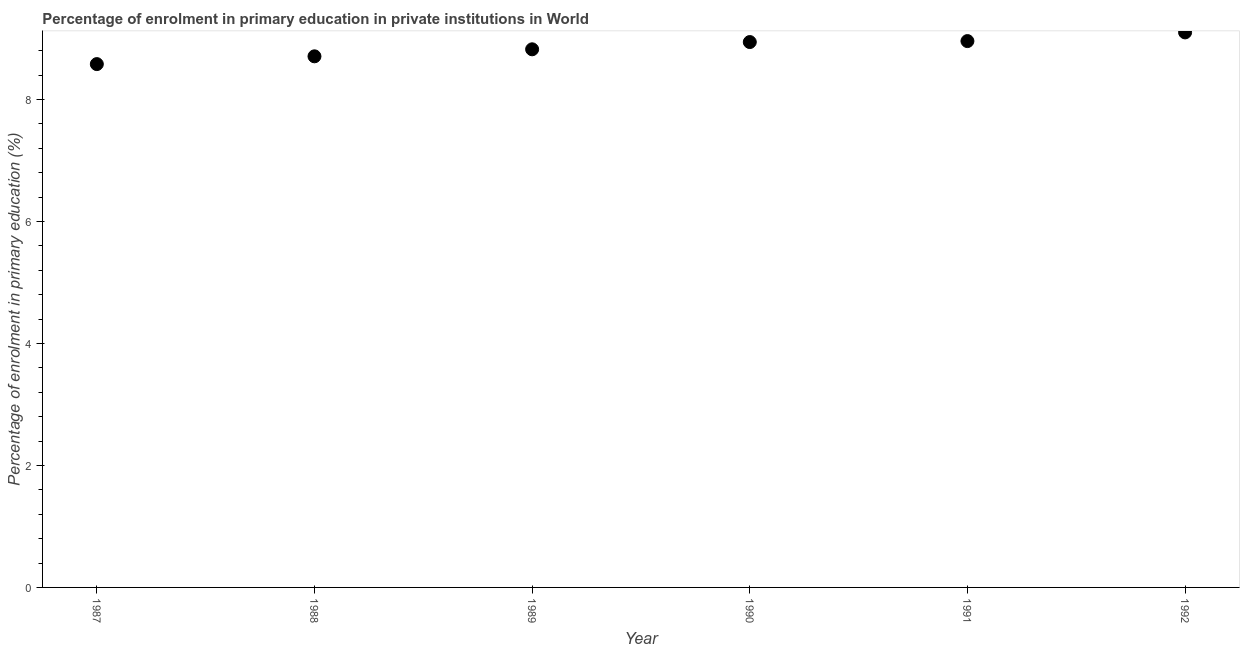What is the enrolment percentage in primary education in 1990?
Provide a succinct answer. 8.94. Across all years, what is the maximum enrolment percentage in primary education?
Offer a very short reply. 9.1. Across all years, what is the minimum enrolment percentage in primary education?
Offer a terse response. 8.58. In which year was the enrolment percentage in primary education maximum?
Offer a very short reply. 1992. In which year was the enrolment percentage in primary education minimum?
Keep it short and to the point. 1987. What is the sum of the enrolment percentage in primary education?
Your answer should be very brief. 53.1. What is the difference between the enrolment percentage in primary education in 1987 and 1992?
Your response must be concise. -0.52. What is the average enrolment percentage in primary education per year?
Offer a very short reply. 8.85. What is the median enrolment percentage in primary education?
Make the answer very short. 8.88. Do a majority of the years between 1990 and 1989 (inclusive) have enrolment percentage in primary education greater than 4.8 %?
Offer a very short reply. No. What is the ratio of the enrolment percentage in primary education in 1988 to that in 1991?
Provide a succinct answer. 0.97. What is the difference between the highest and the second highest enrolment percentage in primary education?
Offer a very short reply. 0.14. What is the difference between the highest and the lowest enrolment percentage in primary education?
Give a very brief answer. 0.52. Does the enrolment percentage in primary education monotonically increase over the years?
Offer a very short reply. Yes. How many years are there in the graph?
Provide a succinct answer. 6. What is the difference between two consecutive major ticks on the Y-axis?
Keep it short and to the point. 2. Are the values on the major ticks of Y-axis written in scientific E-notation?
Your response must be concise. No. Does the graph contain grids?
Offer a very short reply. No. What is the title of the graph?
Your response must be concise. Percentage of enrolment in primary education in private institutions in World. What is the label or title of the X-axis?
Your answer should be very brief. Year. What is the label or title of the Y-axis?
Offer a very short reply. Percentage of enrolment in primary education (%). What is the Percentage of enrolment in primary education (%) in 1987?
Give a very brief answer. 8.58. What is the Percentage of enrolment in primary education (%) in 1988?
Your answer should be compact. 8.71. What is the Percentage of enrolment in primary education (%) in 1989?
Offer a terse response. 8.82. What is the Percentage of enrolment in primary education (%) in 1990?
Offer a very short reply. 8.94. What is the Percentage of enrolment in primary education (%) in 1991?
Ensure brevity in your answer.  8.96. What is the Percentage of enrolment in primary education (%) in 1992?
Ensure brevity in your answer.  9.1. What is the difference between the Percentage of enrolment in primary education (%) in 1987 and 1988?
Your response must be concise. -0.13. What is the difference between the Percentage of enrolment in primary education (%) in 1987 and 1989?
Give a very brief answer. -0.24. What is the difference between the Percentage of enrolment in primary education (%) in 1987 and 1990?
Your answer should be compact. -0.36. What is the difference between the Percentage of enrolment in primary education (%) in 1987 and 1991?
Make the answer very short. -0.38. What is the difference between the Percentage of enrolment in primary education (%) in 1987 and 1992?
Make the answer very short. -0.52. What is the difference between the Percentage of enrolment in primary education (%) in 1988 and 1989?
Give a very brief answer. -0.11. What is the difference between the Percentage of enrolment in primary education (%) in 1988 and 1990?
Provide a short and direct response. -0.23. What is the difference between the Percentage of enrolment in primary education (%) in 1988 and 1991?
Offer a terse response. -0.25. What is the difference between the Percentage of enrolment in primary education (%) in 1988 and 1992?
Ensure brevity in your answer.  -0.39. What is the difference between the Percentage of enrolment in primary education (%) in 1989 and 1990?
Your answer should be compact. -0.12. What is the difference between the Percentage of enrolment in primary education (%) in 1989 and 1991?
Keep it short and to the point. -0.13. What is the difference between the Percentage of enrolment in primary education (%) in 1989 and 1992?
Your response must be concise. -0.28. What is the difference between the Percentage of enrolment in primary education (%) in 1990 and 1991?
Your answer should be compact. -0.02. What is the difference between the Percentage of enrolment in primary education (%) in 1990 and 1992?
Keep it short and to the point. -0.16. What is the difference between the Percentage of enrolment in primary education (%) in 1991 and 1992?
Ensure brevity in your answer.  -0.14. What is the ratio of the Percentage of enrolment in primary education (%) in 1987 to that in 1988?
Your answer should be very brief. 0.98. What is the ratio of the Percentage of enrolment in primary education (%) in 1987 to that in 1991?
Offer a terse response. 0.96. What is the ratio of the Percentage of enrolment in primary education (%) in 1987 to that in 1992?
Keep it short and to the point. 0.94. What is the ratio of the Percentage of enrolment in primary education (%) in 1988 to that in 1989?
Your answer should be very brief. 0.99. What is the ratio of the Percentage of enrolment in primary education (%) in 1988 to that in 1990?
Ensure brevity in your answer.  0.97. What is the ratio of the Percentage of enrolment in primary education (%) in 1988 to that in 1991?
Your response must be concise. 0.97. What is the ratio of the Percentage of enrolment in primary education (%) in 1989 to that in 1990?
Your response must be concise. 0.99. What is the ratio of the Percentage of enrolment in primary education (%) in 1989 to that in 1992?
Your response must be concise. 0.97. What is the ratio of the Percentage of enrolment in primary education (%) in 1990 to that in 1992?
Make the answer very short. 0.98. What is the ratio of the Percentage of enrolment in primary education (%) in 1991 to that in 1992?
Your response must be concise. 0.98. 